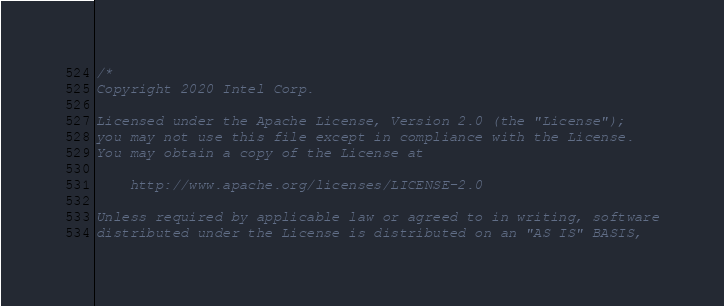<code> <loc_0><loc_0><loc_500><loc_500><_C_>/*
Copyright 2020 Intel Corp.

Licensed under the Apache License, Version 2.0 (the "License");
you may not use this file except in compliance with the License.
You may obtain a copy of the License at

    http://www.apache.org/licenses/LICENSE-2.0

Unless required by applicable law or agreed to in writing, software
distributed under the License is distributed on an "AS IS" BASIS,</code> 